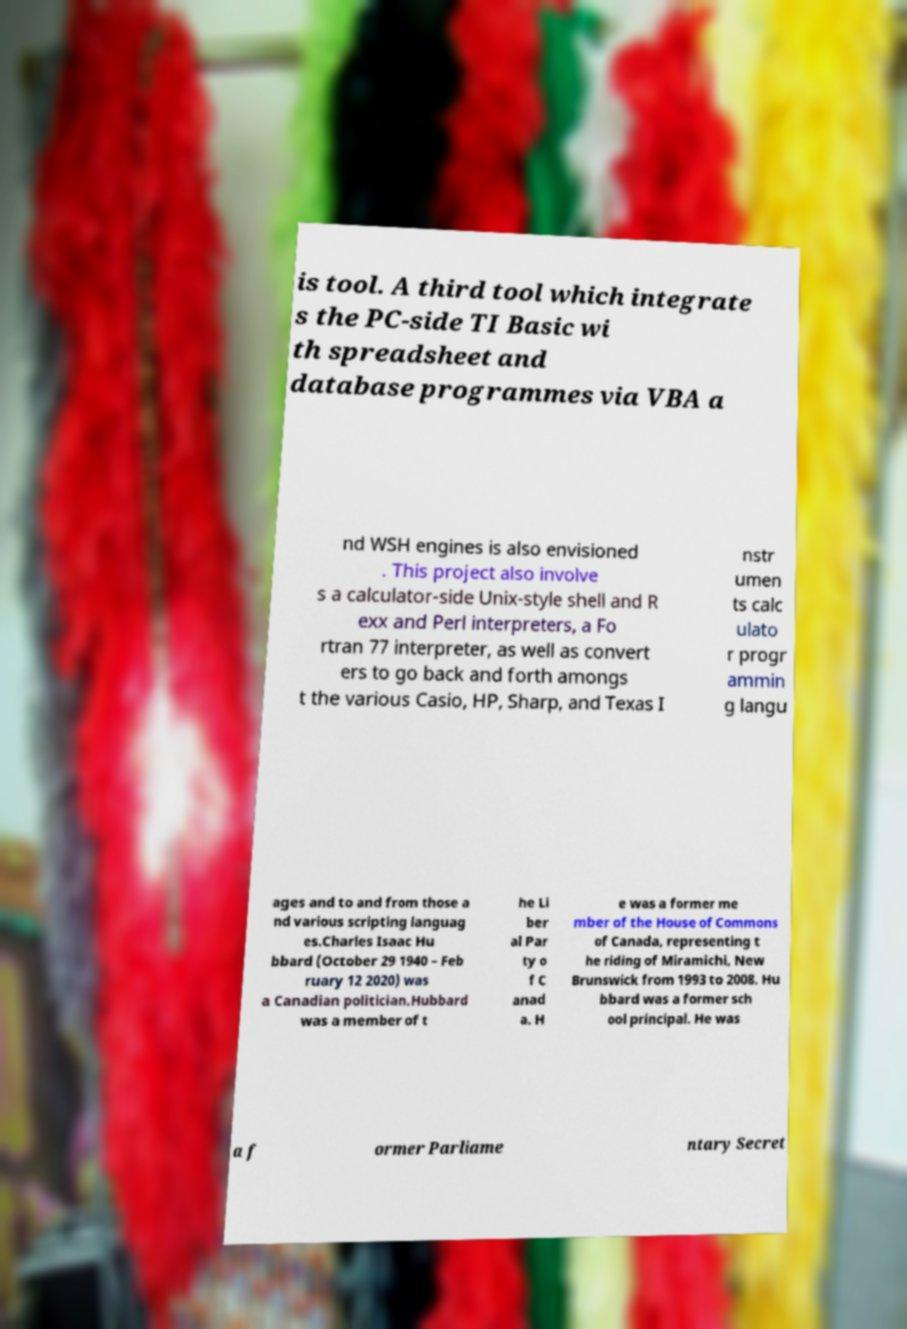Please read and relay the text visible in this image. What does it say? is tool. A third tool which integrate s the PC-side TI Basic wi th spreadsheet and database programmes via VBA a nd WSH engines is also envisioned . This project also involve s a calculator-side Unix-style shell and R exx and Perl interpreters, a Fo rtran 77 interpreter, as well as convert ers to go back and forth amongs t the various Casio, HP, Sharp, and Texas I nstr umen ts calc ulato r progr ammin g langu ages and to and from those a nd various scripting languag es.Charles Isaac Hu bbard (October 29 1940 – Feb ruary 12 2020) was a Canadian politician.Hubbard was a member of t he Li ber al Par ty o f C anad a. H e was a former me mber of the House of Commons of Canada, representing t he riding of Miramichi, New Brunswick from 1993 to 2008. Hu bbard was a former sch ool principal. He was a f ormer Parliame ntary Secret 